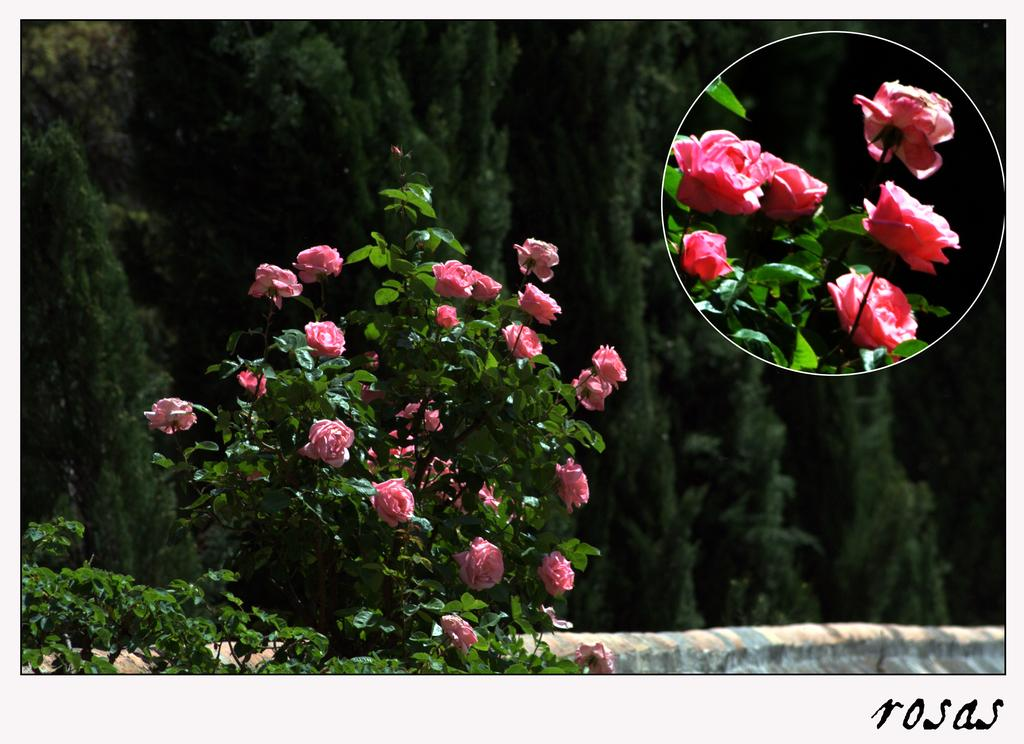What type of flora is present in the image? There are flowers in the image. What color are the flowers? The flowers are pink in color. What can be seen in the background of the image? There are trees in the background of the image. What color are the trees? The trees are green in color. What type of tin can be seen in the image? There is no tin present in the image. How does the self-awareness of the flowers manifest in the image? The flowers in the image do not exhibit self-awareness, as they are inanimate objects. 